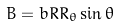<formula> <loc_0><loc_0><loc_500><loc_500>B = b R R _ { \theta } \sin \theta</formula> 